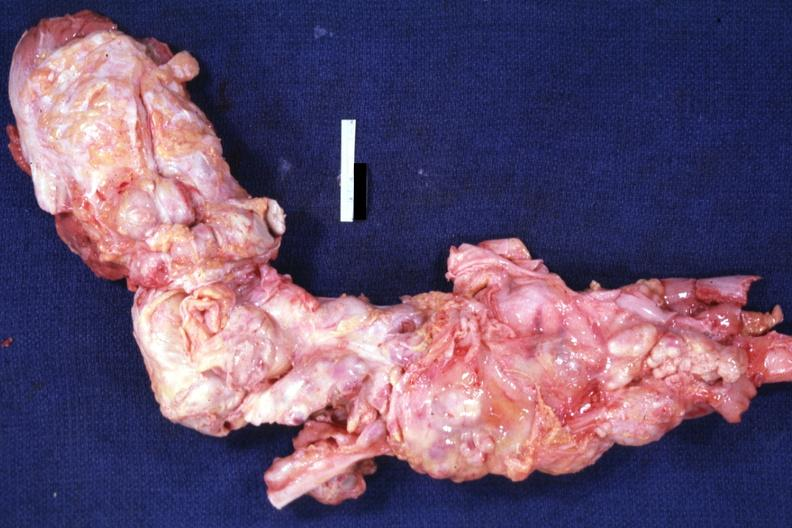what is present?
Answer the question using a single word or phrase. Lymph node 